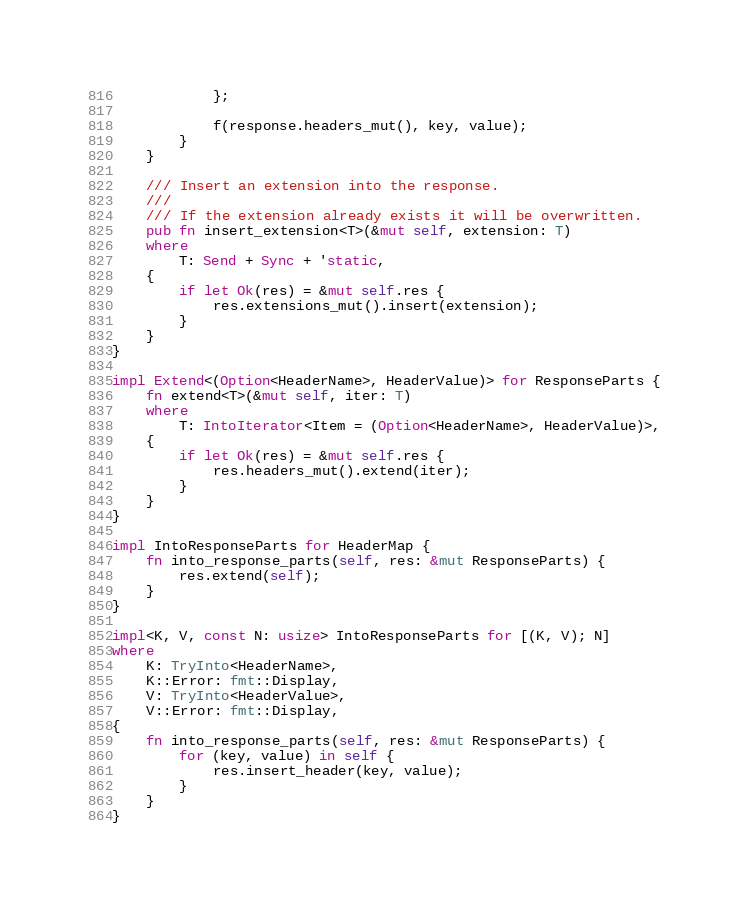Convert code to text. <code><loc_0><loc_0><loc_500><loc_500><_Rust_>            };

            f(response.headers_mut(), key, value);
        }
    }

    /// Insert an extension into the response.
    ///
    /// If the extension already exists it will be overwritten.
    pub fn insert_extension<T>(&mut self, extension: T)
    where
        T: Send + Sync + 'static,
    {
        if let Ok(res) = &mut self.res {
            res.extensions_mut().insert(extension);
        }
    }
}

impl Extend<(Option<HeaderName>, HeaderValue)> for ResponseParts {
    fn extend<T>(&mut self, iter: T)
    where
        T: IntoIterator<Item = (Option<HeaderName>, HeaderValue)>,
    {
        if let Ok(res) = &mut self.res {
            res.headers_mut().extend(iter);
        }
    }
}

impl IntoResponseParts for HeaderMap {
    fn into_response_parts(self, res: &mut ResponseParts) {
        res.extend(self);
    }
}

impl<K, V, const N: usize> IntoResponseParts for [(K, V); N]
where
    K: TryInto<HeaderName>,
    K::Error: fmt::Display,
    V: TryInto<HeaderValue>,
    V::Error: fmt::Display,
{
    fn into_response_parts(self, res: &mut ResponseParts) {
        for (key, value) in self {
            res.insert_header(key, value);
        }
    }
}
</code> 